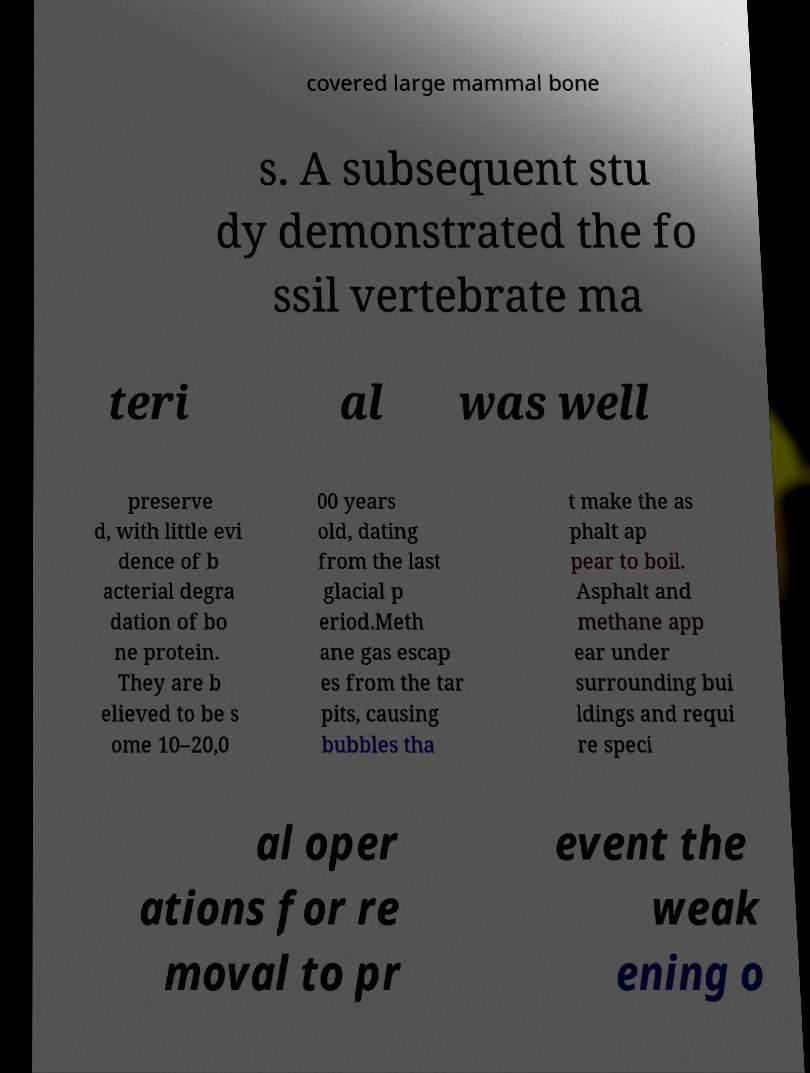Could you extract and type out the text from this image? covered large mammal bone s. A subsequent stu dy demonstrated the fo ssil vertebrate ma teri al was well preserve d, with little evi dence of b acterial degra dation of bo ne protein. They are b elieved to be s ome 10–20,0 00 years old, dating from the last glacial p eriod.Meth ane gas escap es from the tar pits, causing bubbles tha t make the as phalt ap pear to boil. Asphalt and methane app ear under surrounding bui ldings and requi re speci al oper ations for re moval to pr event the weak ening o 